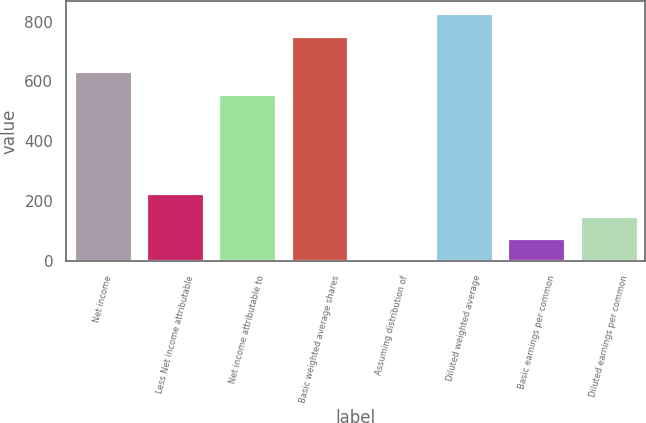<chart> <loc_0><loc_0><loc_500><loc_500><bar_chart><fcel>Net income<fcel>Less Net income attributable<fcel>Net income attributable to<fcel>Basic weighted average shares<fcel>Assuming distribution of<fcel>Diluted weighted average<fcel>Basic earnings per common<fcel>Diluted earnings per common<nl><fcel>633.24<fcel>226.22<fcel>558<fcel>752.4<fcel>0.5<fcel>827.64<fcel>75.74<fcel>150.98<nl></chart> 